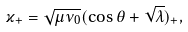<formula> <loc_0><loc_0><loc_500><loc_500>\varkappa _ { + } = \sqrt { \mu \nu _ { 0 } } ( \cos \theta + \sqrt { \lambda } ) _ { + } ,</formula> 